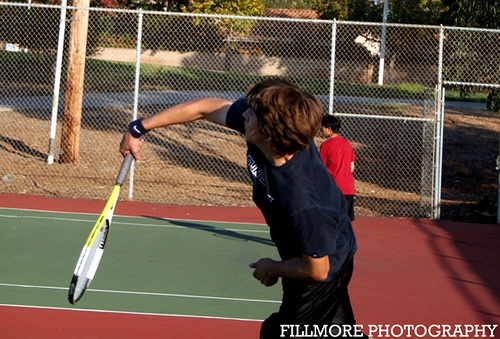Describe the objects in this image and their specific colors. I can see people in maroon, black, salmon, and gray tones, tennis racket in maroon, white, darkgray, yellow, and khaki tones, and people in maroon, brown, and black tones in this image. 